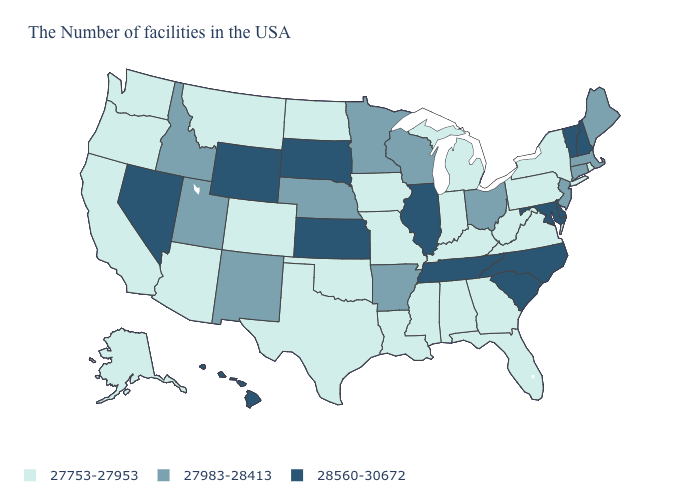Name the states that have a value in the range 27983-28413?
Give a very brief answer. Maine, Massachusetts, Connecticut, New Jersey, Ohio, Wisconsin, Arkansas, Minnesota, Nebraska, New Mexico, Utah, Idaho. What is the highest value in the MidWest ?
Be succinct. 28560-30672. Is the legend a continuous bar?
Concise answer only. No. Does South Dakota have the highest value in the USA?
Keep it brief. Yes. What is the value of Vermont?
Quick response, please. 28560-30672. Is the legend a continuous bar?
Be succinct. No. What is the value of Tennessee?
Short answer required. 28560-30672. What is the lowest value in the South?
Be succinct. 27753-27953. Among the states that border Connecticut , which have the highest value?
Quick response, please. Massachusetts. What is the value of Mississippi?
Keep it brief. 27753-27953. What is the value of North Carolina?
Quick response, please. 28560-30672. What is the value of Kansas?
Concise answer only. 28560-30672. What is the value of Texas?
Quick response, please. 27753-27953. Name the states that have a value in the range 27983-28413?
Short answer required. Maine, Massachusetts, Connecticut, New Jersey, Ohio, Wisconsin, Arkansas, Minnesota, Nebraska, New Mexico, Utah, Idaho. Does South Dakota have a higher value than New Hampshire?
Concise answer only. No. 